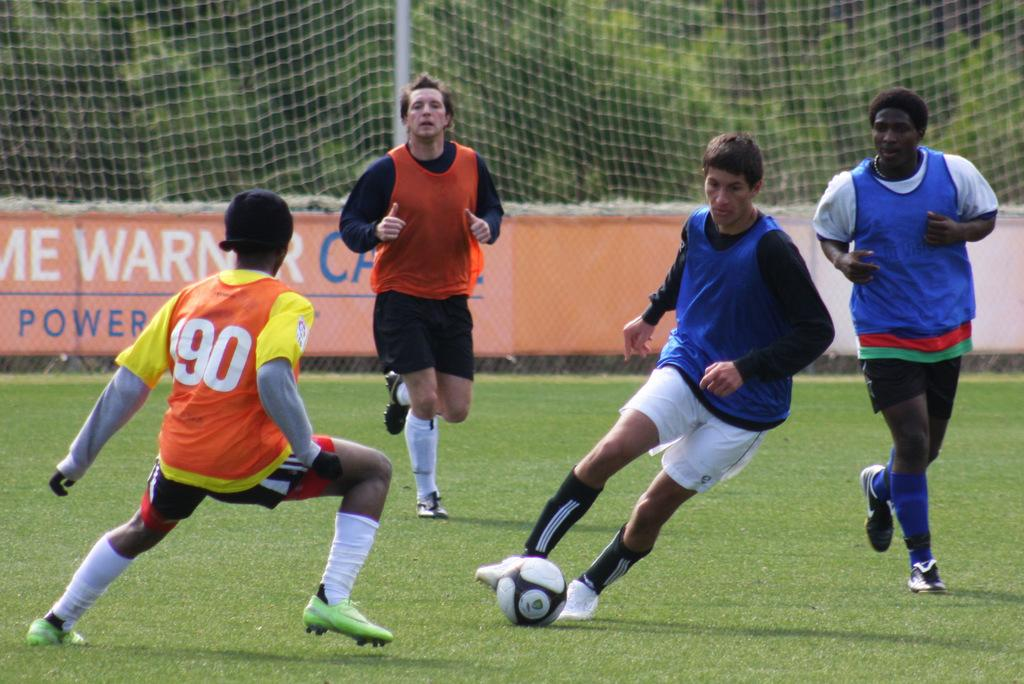<image>
Create a compact narrative representing the image presented. soccer play in black and blue kicking ball while play #190 in orange and yellow jersey tries to defend against him 